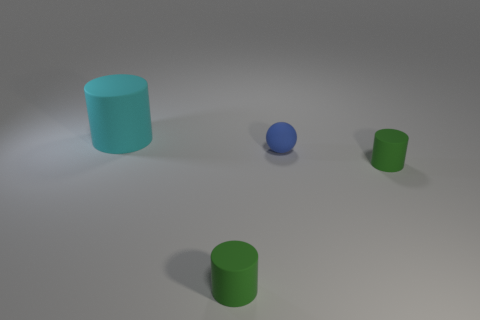Add 4 gray matte objects. How many objects exist? 8 Subtract all spheres. How many objects are left? 3 Add 1 green rubber objects. How many green rubber objects exist? 3 Subtract 0 green spheres. How many objects are left? 4 Subtract all small cyan matte spheres. Subtract all cyan cylinders. How many objects are left? 3 Add 1 cyan cylinders. How many cyan cylinders are left? 2 